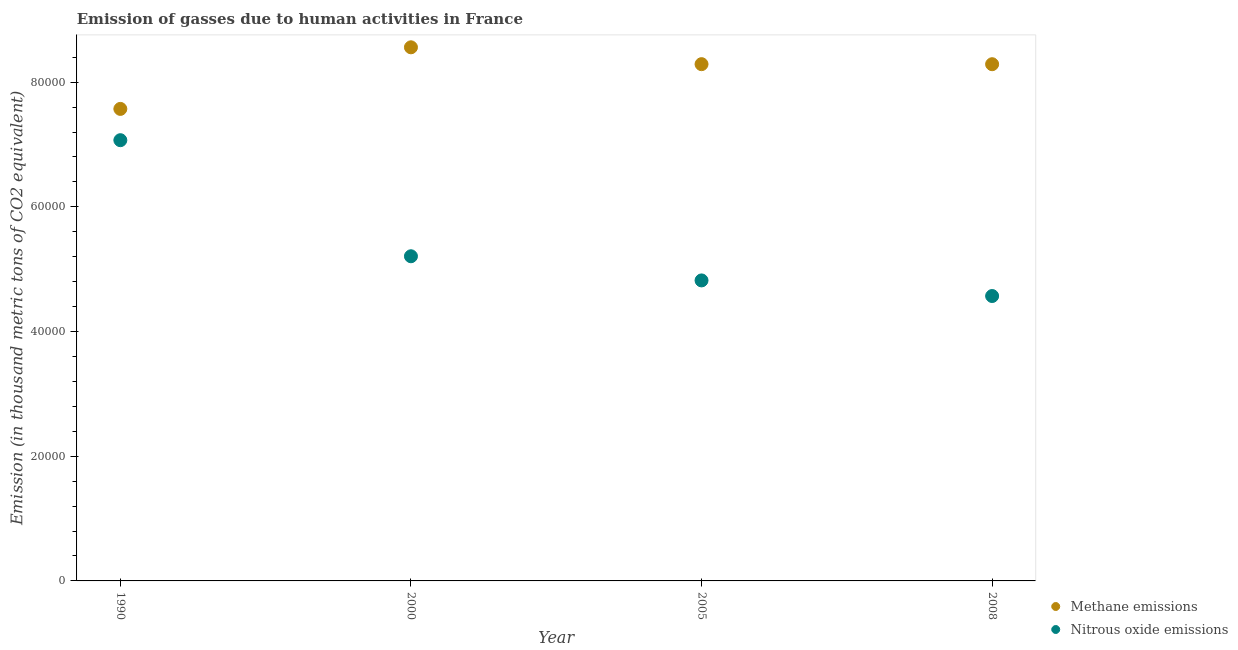What is the amount of nitrous oxide emissions in 1990?
Keep it short and to the point. 7.07e+04. Across all years, what is the maximum amount of nitrous oxide emissions?
Your answer should be compact. 7.07e+04. Across all years, what is the minimum amount of methane emissions?
Your response must be concise. 7.57e+04. What is the total amount of methane emissions in the graph?
Offer a terse response. 3.27e+05. What is the difference between the amount of methane emissions in 2000 and that in 2008?
Your answer should be compact. 2710.3. What is the difference between the amount of nitrous oxide emissions in 2008 and the amount of methane emissions in 2005?
Give a very brief answer. -3.72e+04. What is the average amount of nitrous oxide emissions per year?
Make the answer very short. 5.42e+04. In the year 2005, what is the difference between the amount of nitrous oxide emissions and amount of methane emissions?
Your answer should be very brief. -3.47e+04. In how many years, is the amount of methane emissions greater than 76000 thousand metric tons?
Give a very brief answer. 3. What is the ratio of the amount of nitrous oxide emissions in 2005 to that in 2008?
Your answer should be very brief. 1.05. Is the difference between the amount of methane emissions in 1990 and 2008 greater than the difference between the amount of nitrous oxide emissions in 1990 and 2008?
Offer a terse response. No. What is the difference between the highest and the second highest amount of methane emissions?
Provide a short and direct response. 2703. What is the difference between the highest and the lowest amount of methane emissions?
Offer a terse response. 9878.9. Does the amount of methane emissions monotonically increase over the years?
Your answer should be very brief. No. Is the amount of nitrous oxide emissions strictly less than the amount of methane emissions over the years?
Your response must be concise. Yes. How many years are there in the graph?
Offer a terse response. 4. What is the difference between two consecutive major ticks on the Y-axis?
Your answer should be very brief. 2.00e+04. Does the graph contain any zero values?
Offer a very short reply. No. Does the graph contain grids?
Your answer should be very brief. No. Where does the legend appear in the graph?
Offer a terse response. Bottom right. What is the title of the graph?
Make the answer very short. Emission of gasses due to human activities in France. What is the label or title of the Y-axis?
Provide a succinct answer. Emission (in thousand metric tons of CO2 equivalent). What is the Emission (in thousand metric tons of CO2 equivalent) in Methane emissions in 1990?
Ensure brevity in your answer.  7.57e+04. What is the Emission (in thousand metric tons of CO2 equivalent) in Nitrous oxide emissions in 1990?
Keep it short and to the point. 7.07e+04. What is the Emission (in thousand metric tons of CO2 equivalent) in Methane emissions in 2000?
Your answer should be compact. 8.56e+04. What is the Emission (in thousand metric tons of CO2 equivalent) in Nitrous oxide emissions in 2000?
Offer a terse response. 5.21e+04. What is the Emission (in thousand metric tons of CO2 equivalent) of Methane emissions in 2005?
Offer a very short reply. 8.29e+04. What is the Emission (in thousand metric tons of CO2 equivalent) in Nitrous oxide emissions in 2005?
Provide a short and direct response. 4.82e+04. What is the Emission (in thousand metric tons of CO2 equivalent) of Methane emissions in 2008?
Make the answer very short. 8.29e+04. What is the Emission (in thousand metric tons of CO2 equivalent) in Nitrous oxide emissions in 2008?
Your response must be concise. 4.57e+04. Across all years, what is the maximum Emission (in thousand metric tons of CO2 equivalent) in Methane emissions?
Provide a succinct answer. 8.56e+04. Across all years, what is the maximum Emission (in thousand metric tons of CO2 equivalent) in Nitrous oxide emissions?
Your answer should be very brief. 7.07e+04. Across all years, what is the minimum Emission (in thousand metric tons of CO2 equivalent) in Methane emissions?
Your answer should be compact. 7.57e+04. Across all years, what is the minimum Emission (in thousand metric tons of CO2 equivalent) in Nitrous oxide emissions?
Provide a short and direct response. 4.57e+04. What is the total Emission (in thousand metric tons of CO2 equivalent) of Methane emissions in the graph?
Provide a succinct answer. 3.27e+05. What is the total Emission (in thousand metric tons of CO2 equivalent) of Nitrous oxide emissions in the graph?
Offer a very short reply. 2.17e+05. What is the difference between the Emission (in thousand metric tons of CO2 equivalent) in Methane emissions in 1990 and that in 2000?
Make the answer very short. -9878.9. What is the difference between the Emission (in thousand metric tons of CO2 equivalent) in Nitrous oxide emissions in 1990 and that in 2000?
Give a very brief answer. 1.86e+04. What is the difference between the Emission (in thousand metric tons of CO2 equivalent) in Methane emissions in 1990 and that in 2005?
Make the answer very short. -7175.9. What is the difference between the Emission (in thousand metric tons of CO2 equivalent) of Nitrous oxide emissions in 1990 and that in 2005?
Make the answer very short. 2.25e+04. What is the difference between the Emission (in thousand metric tons of CO2 equivalent) in Methane emissions in 1990 and that in 2008?
Provide a succinct answer. -7168.6. What is the difference between the Emission (in thousand metric tons of CO2 equivalent) in Nitrous oxide emissions in 1990 and that in 2008?
Offer a terse response. 2.50e+04. What is the difference between the Emission (in thousand metric tons of CO2 equivalent) in Methane emissions in 2000 and that in 2005?
Offer a terse response. 2703. What is the difference between the Emission (in thousand metric tons of CO2 equivalent) in Nitrous oxide emissions in 2000 and that in 2005?
Your response must be concise. 3875.3. What is the difference between the Emission (in thousand metric tons of CO2 equivalent) of Methane emissions in 2000 and that in 2008?
Keep it short and to the point. 2710.3. What is the difference between the Emission (in thousand metric tons of CO2 equivalent) in Nitrous oxide emissions in 2000 and that in 2008?
Provide a succinct answer. 6378.7. What is the difference between the Emission (in thousand metric tons of CO2 equivalent) in Methane emissions in 2005 and that in 2008?
Provide a short and direct response. 7.3. What is the difference between the Emission (in thousand metric tons of CO2 equivalent) of Nitrous oxide emissions in 2005 and that in 2008?
Your answer should be compact. 2503.4. What is the difference between the Emission (in thousand metric tons of CO2 equivalent) of Methane emissions in 1990 and the Emission (in thousand metric tons of CO2 equivalent) of Nitrous oxide emissions in 2000?
Your answer should be very brief. 2.36e+04. What is the difference between the Emission (in thousand metric tons of CO2 equivalent) of Methane emissions in 1990 and the Emission (in thousand metric tons of CO2 equivalent) of Nitrous oxide emissions in 2005?
Make the answer very short. 2.75e+04. What is the difference between the Emission (in thousand metric tons of CO2 equivalent) in Methane emissions in 1990 and the Emission (in thousand metric tons of CO2 equivalent) in Nitrous oxide emissions in 2008?
Make the answer very short. 3.00e+04. What is the difference between the Emission (in thousand metric tons of CO2 equivalent) in Methane emissions in 2000 and the Emission (in thousand metric tons of CO2 equivalent) in Nitrous oxide emissions in 2005?
Offer a very short reply. 3.74e+04. What is the difference between the Emission (in thousand metric tons of CO2 equivalent) of Methane emissions in 2000 and the Emission (in thousand metric tons of CO2 equivalent) of Nitrous oxide emissions in 2008?
Your answer should be very brief. 3.99e+04. What is the difference between the Emission (in thousand metric tons of CO2 equivalent) of Methane emissions in 2005 and the Emission (in thousand metric tons of CO2 equivalent) of Nitrous oxide emissions in 2008?
Your response must be concise. 3.72e+04. What is the average Emission (in thousand metric tons of CO2 equivalent) of Methane emissions per year?
Your response must be concise. 8.18e+04. What is the average Emission (in thousand metric tons of CO2 equivalent) of Nitrous oxide emissions per year?
Keep it short and to the point. 5.42e+04. In the year 1990, what is the difference between the Emission (in thousand metric tons of CO2 equivalent) in Methane emissions and Emission (in thousand metric tons of CO2 equivalent) in Nitrous oxide emissions?
Your response must be concise. 5018.2. In the year 2000, what is the difference between the Emission (in thousand metric tons of CO2 equivalent) in Methane emissions and Emission (in thousand metric tons of CO2 equivalent) in Nitrous oxide emissions?
Make the answer very short. 3.35e+04. In the year 2005, what is the difference between the Emission (in thousand metric tons of CO2 equivalent) in Methane emissions and Emission (in thousand metric tons of CO2 equivalent) in Nitrous oxide emissions?
Offer a terse response. 3.47e+04. In the year 2008, what is the difference between the Emission (in thousand metric tons of CO2 equivalent) in Methane emissions and Emission (in thousand metric tons of CO2 equivalent) in Nitrous oxide emissions?
Offer a very short reply. 3.72e+04. What is the ratio of the Emission (in thousand metric tons of CO2 equivalent) in Methane emissions in 1990 to that in 2000?
Your response must be concise. 0.88. What is the ratio of the Emission (in thousand metric tons of CO2 equivalent) in Nitrous oxide emissions in 1990 to that in 2000?
Keep it short and to the point. 1.36. What is the ratio of the Emission (in thousand metric tons of CO2 equivalent) of Methane emissions in 1990 to that in 2005?
Make the answer very short. 0.91. What is the ratio of the Emission (in thousand metric tons of CO2 equivalent) in Nitrous oxide emissions in 1990 to that in 2005?
Provide a succinct answer. 1.47. What is the ratio of the Emission (in thousand metric tons of CO2 equivalent) of Methane emissions in 1990 to that in 2008?
Offer a terse response. 0.91. What is the ratio of the Emission (in thousand metric tons of CO2 equivalent) of Nitrous oxide emissions in 1990 to that in 2008?
Your answer should be compact. 1.55. What is the ratio of the Emission (in thousand metric tons of CO2 equivalent) in Methane emissions in 2000 to that in 2005?
Provide a succinct answer. 1.03. What is the ratio of the Emission (in thousand metric tons of CO2 equivalent) of Nitrous oxide emissions in 2000 to that in 2005?
Make the answer very short. 1.08. What is the ratio of the Emission (in thousand metric tons of CO2 equivalent) in Methane emissions in 2000 to that in 2008?
Offer a terse response. 1.03. What is the ratio of the Emission (in thousand metric tons of CO2 equivalent) in Nitrous oxide emissions in 2000 to that in 2008?
Provide a succinct answer. 1.14. What is the ratio of the Emission (in thousand metric tons of CO2 equivalent) in Nitrous oxide emissions in 2005 to that in 2008?
Your answer should be very brief. 1.05. What is the difference between the highest and the second highest Emission (in thousand metric tons of CO2 equivalent) in Methane emissions?
Keep it short and to the point. 2703. What is the difference between the highest and the second highest Emission (in thousand metric tons of CO2 equivalent) of Nitrous oxide emissions?
Provide a short and direct response. 1.86e+04. What is the difference between the highest and the lowest Emission (in thousand metric tons of CO2 equivalent) in Methane emissions?
Your response must be concise. 9878.9. What is the difference between the highest and the lowest Emission (in thousand metric tons of CO2 equivalent) of Nitrous oxide emissions?
Your response must be concise. 2.50e+04. 